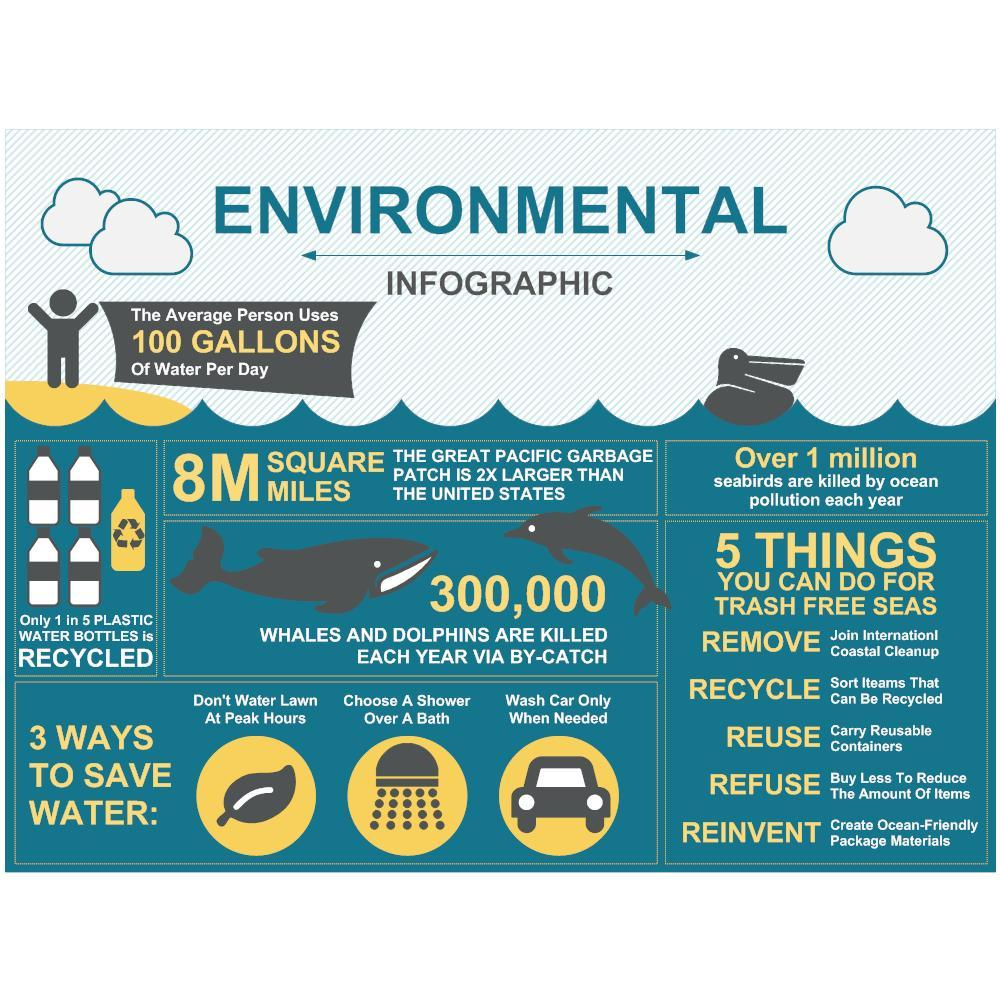what are the first three things in the list of different things to do for trash free seas?
Answer the question with a short phrase. remove, recycle, reuse what is the second point given in different ways to save water? choose a shower over a bath what percent of plastic water bottle is recycled? 20 what are the second last thing in the list of different things to do for trash free seas? refuse what are the last two things in the list of different things to do for trash free seas? refuse, reinvent 